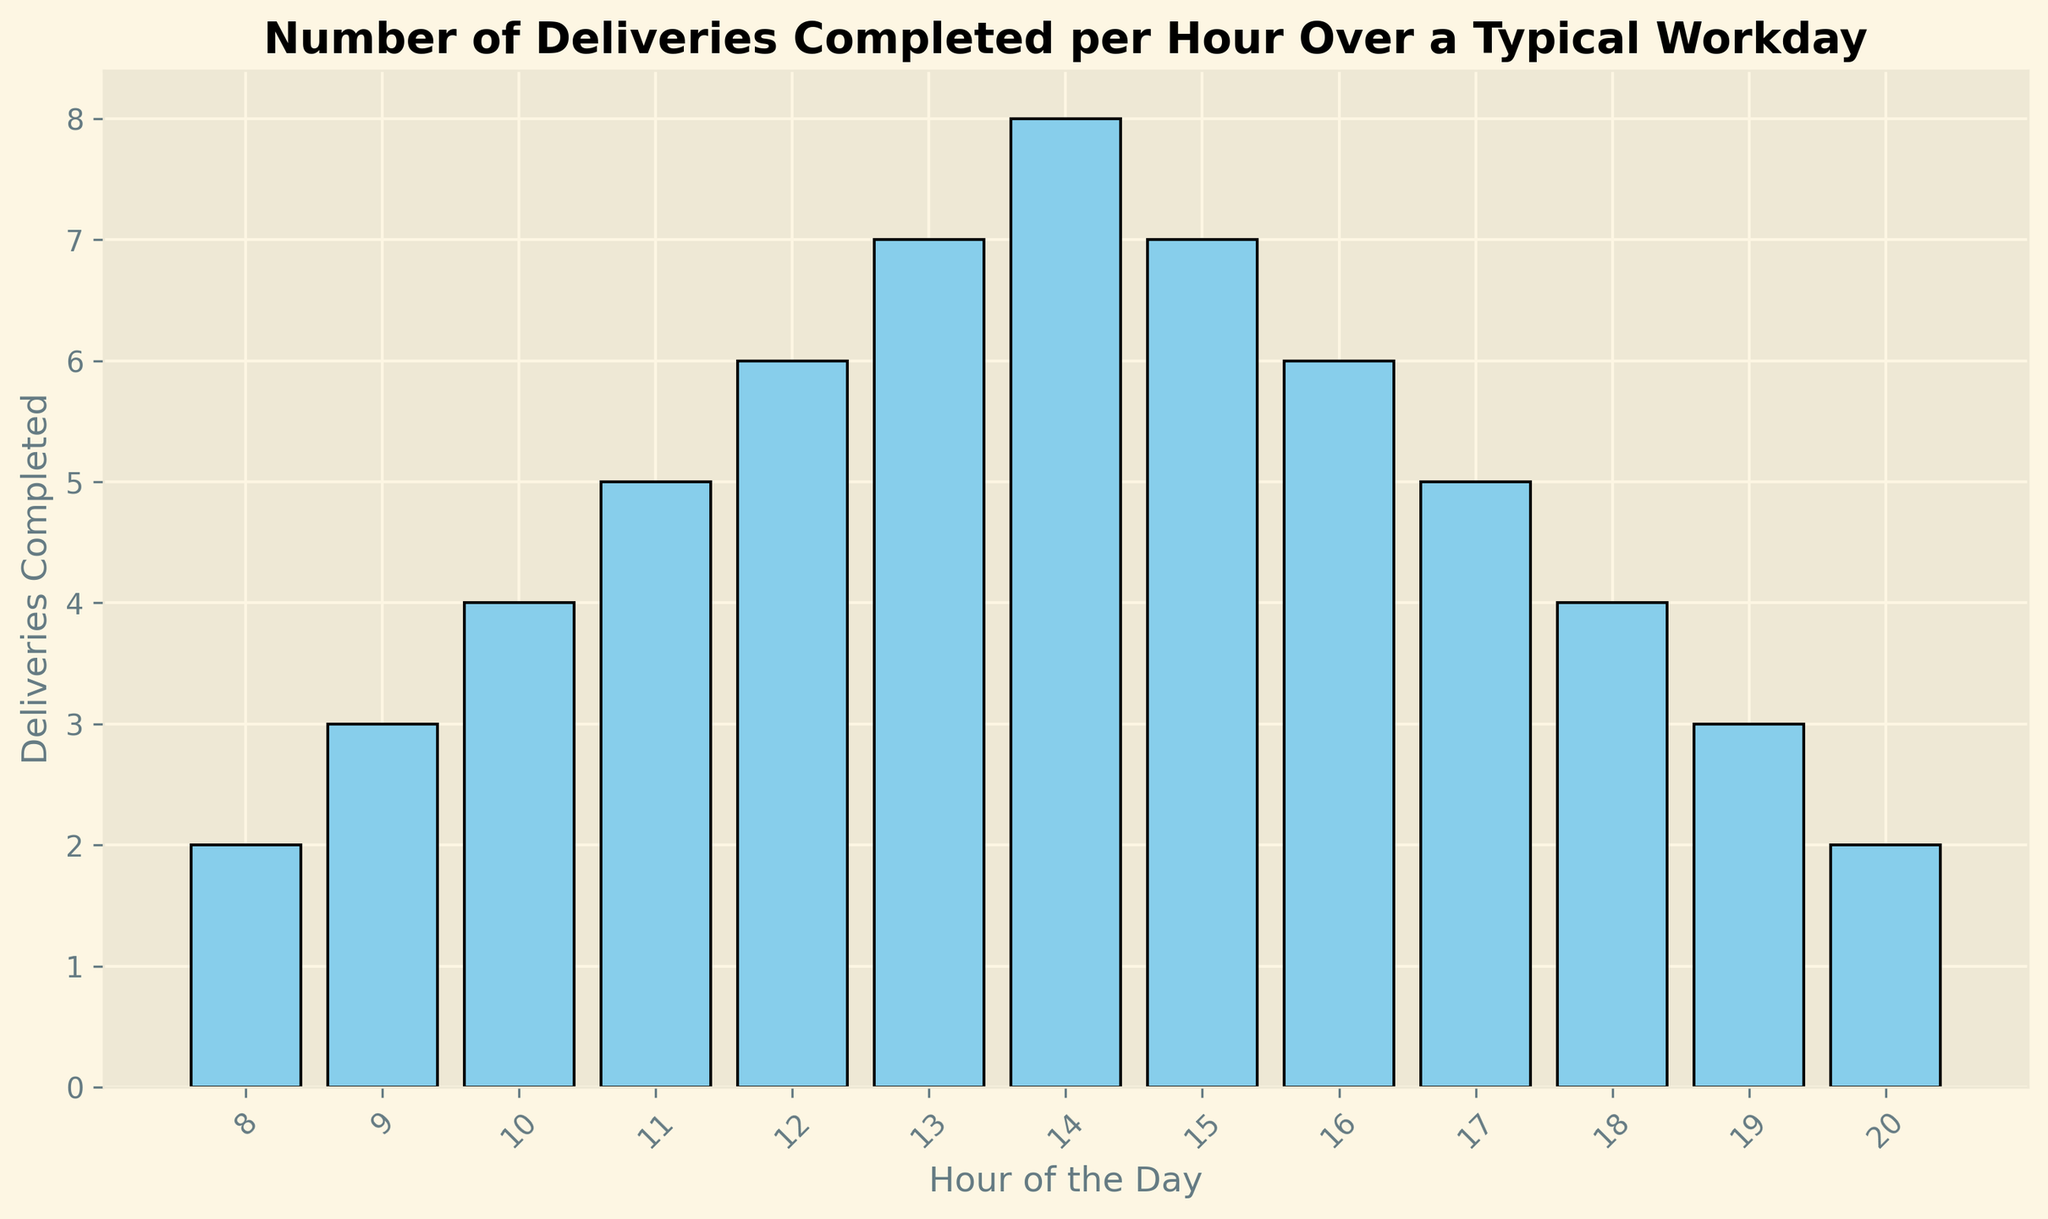What hour has the highest number of deliveries completed? The tallest bar in the histogram represents the hour with the highest number of deliveries completed. The highest number of deliveries is 8, which occurs at 14:00 (2 PM).
Answer: 14:00 (2 PM) At what times do the number of deliveries completed start to decline in the afternoon? To determine when the number of deliveries starts to decline, observe when the bar heights decrease after reaching their peak. The deliveries peak at 14:00 (2 PM) with 8 deliveries and start to decline in the next hour at 15:00 (3 PM).
Answer: 15:00 (3 PM) What is the total number of deliveries completed in the morning (8:00-11:00)? Sum the number of deliveries for each hour from 8:00 to 11:00: 2 (8:00) + 3 (9:00) + 4 (10:00) + 5 (11:00) = 14.
Answer: 14 What is the average number of deliveries completed per hour from 12:00 to 18:00? To find the average, sum the deliveries from 12:00 to 18:00 and divide by the number of hours: (6 + 7 + 8 + 7 + 6 + 5 + 4) / 7 = 43 / 7 ≈ 6.14.
Answer: ~6.14 During how many hours is the number of deliveries completed less than or equal to 3? Identify the bars with heights of 3 or less: 8:00 (2 deliveries), 9:00 (3 deliveries), 19:00 (3 deliveries), and 20:00 (2 deliveries). There are 4 such hours.
Answer: 4 Is the number of deliveries completed at 17:00 higher, lower, or equal to the number of deliveries at 11:00? Compare the heights of the bars at 17:00 and 11:00. At 11:00, there are 5 deliveries, while at 17:00, there are also 5 deliveries. Therefore, the numbers are equal.
Answer: Equal What is the difference in the number of deliveries completed between 10:00 and 14:00? Subtract the deliveries at 10:00 from the deliveries at 14:00: 8 (14:00) - 4 (10:00) = 4.
Answer: 4 Which hours have exactly 6 deliveries completed? Check the bars with a height of 6. These are at 12:00 and 16:00.
Answer: 12:00, 16:00 What is the total number of deliveries completed in the evening (18:00-20:00)? Sum the deliveries for each hour from 18:00 to 20:00: 4 (18:00) + 3 (19:00) + 2 (20:00) = 9.
Answer: 9 How does the number of deliveries completed at 9:00 compare to the number completed at 19:00? Compare the heights of the bars at 9:00 and 19:00. Both hours have 3 deliveries completed.
Answer: Equal What is the overall trend in the number of deliveries completed throughout the workday? From 8:00 to 14:00, the number of deliveries increases, peaking at 14:00 with 8 deliveries. After 14:00, the number of deliveries decreases steadily until 20:00.
Answer: Increase then decrease 